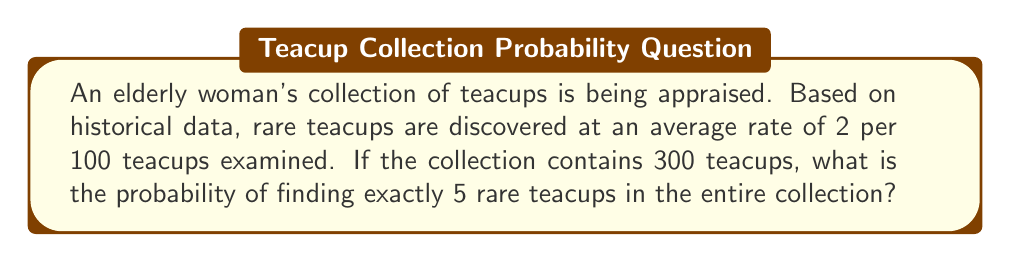Give your solution to this math problem. To solve this problem, we can model the occurrence of rare teacups as a Poisson process. Let's approach this step-by-step:

1) First, we need to determine the rate parameter $\lambda$ for our Poisson distribution:
   - Rate of rare teacups: 2 per 100 teacups
   - Number of teacups in the collection: 300
   - $\lambda = 2 \times (300/100) = 6$

2) The probability of finding exactly $k$ rare teacups in a Poisson process is given by the Poisson probability mass function:

   $$P(X=k) = \frac{e^{-\lambda} \lambda^k}{k!}$$

3) In this case, we want $P(X=5)$ with $\lambda = 6$:

   $$P(X=5) = \frac{e^{-6} 6^5}{5!}$$

4) Let's calculate this step-by-step:
   - $e^{-6} \approx 0.00247875$
   - $6^5 = 7776$
   - $5! = 120$

5) Putting it all together:

   $$P(X=5) = \frac{0.00247875 \times 7776}{120} \approx 0.16062$$

6) Therefore, the probability of finding exactly 5 rare teacups in the collection is approximately 0.16062 or 16.062%.
Answer: 0.16062 